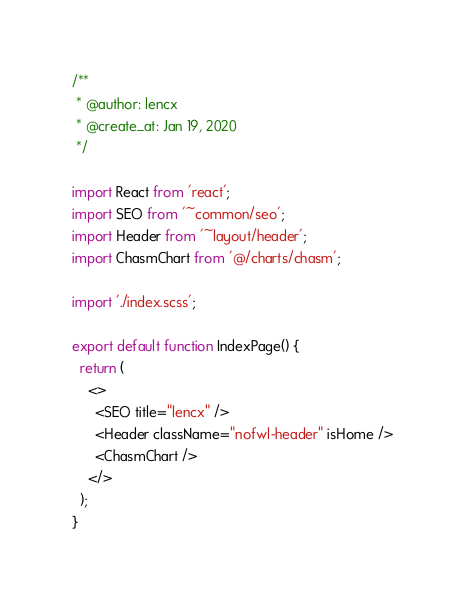Convert code to text. <code><loc_0><loc_0><loc_500><loc_500><_TypeScript_>/**
 * @author: lencx
 * @create_at: Jan 19, 2020
 */

import React from 'react';
import SEO from '~common/seo';
import Header from '~layout/header';
import ChasmChart from '@/charts/chasm';

import './index.scss';

export default function IndexPage() {
  return (
    <>
      <SEO title="lencx" />
      <Header className="nofwl-header" isHome />
      <ChasmChart />
    </>
  );
}
</code> 